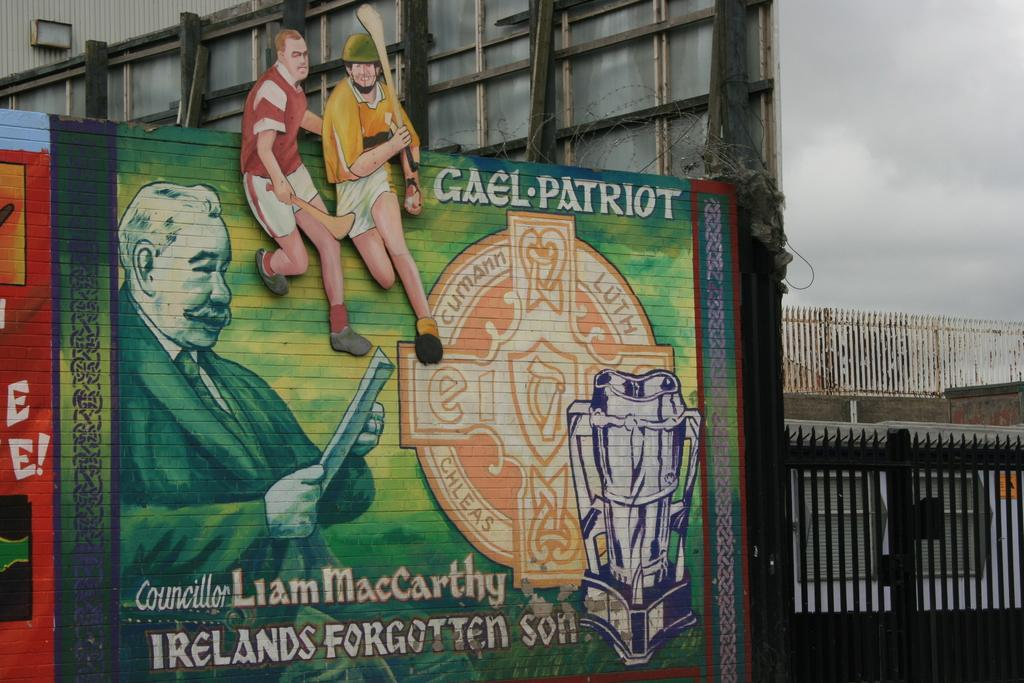Provide a one-sentence caption for the provided image. a green sign outside with Irelands on it. 